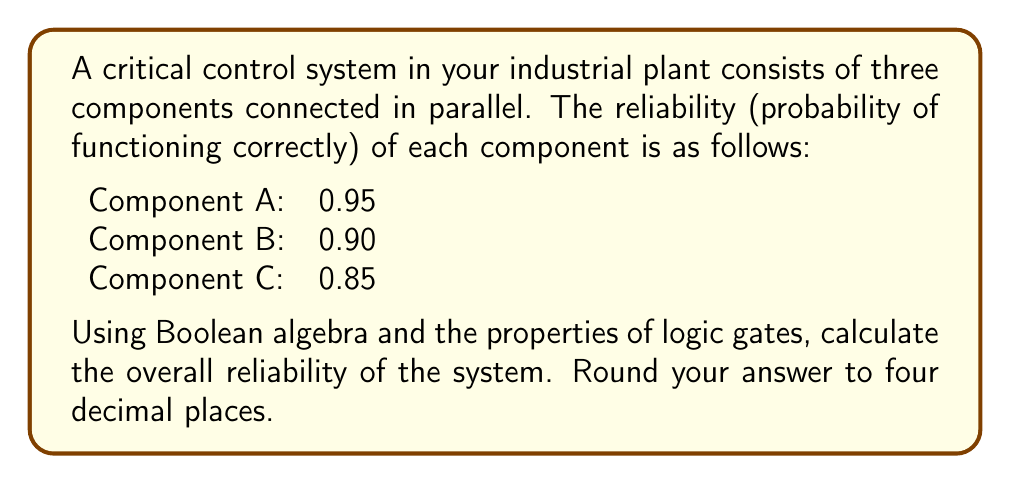Solve this math problem. To solve this problem, we'll use Boolean algebra and the properties of parallel systems:

1) In a parallel system, the system fails only if all components fail. Therefore, we can calculate the probability of system failure and then subtract it from 1 to get the system reliability.

2) Let's define events:
   $A$: Component A functions
   $B$: Component B functions
   $C$: Component C functions

3) The probability of each component failing is:
   $P(\text{not }A) = 1 - 0.95 = 0.05$
   $P(\text{not }B) = 1 - 0.90 = 0.10$
   $P(\text{not }C) = 1 - 0.85 = 0.15$

4) The probability of system failure is the probability that all components fail:
   $P(\text{system failure}) = P(\text{not }A \text{ AND not }B \text{ AND not }C)$

5) Assuming independence of component failures:
   $P(\text{system failure}) = P(\text{not }A) \times P(\text{not }B) \times P(\text{not }C)$

6) Calculating:
   $P(\text{system failure}) = 0.05 \times 0.10 \times 0.15 = 0.00075$

7) The system reliability is the complement of system failure:
   $P(\text{system reliability}) = 1 - P(\text{system failure})$
   $= 1 - 0.00075 = 0.99925$

8) Rounding to four decimal places:
   $P(\text{system reliability}) = 0.9993$

This result can be interpreted using Boolean algebra and logic gates. The system can be represented as an OR gate with three inputs (one for each component). The system functions if at least one component functions, which is equivalent to the complement of all components failing.
Answer: 0.9993 